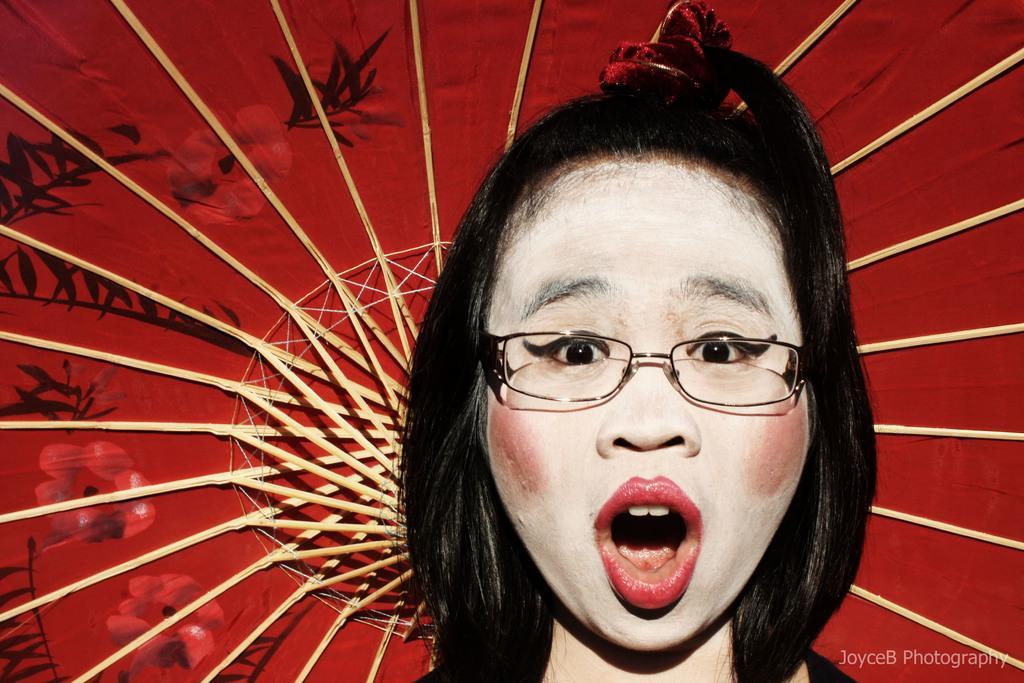How would you summarize this image in a sentence or two? In this image we can see a woman wearing spectacles and in the background, we can see an object which is in red color with some art and there are few sticks and it looks like an umbrella. 